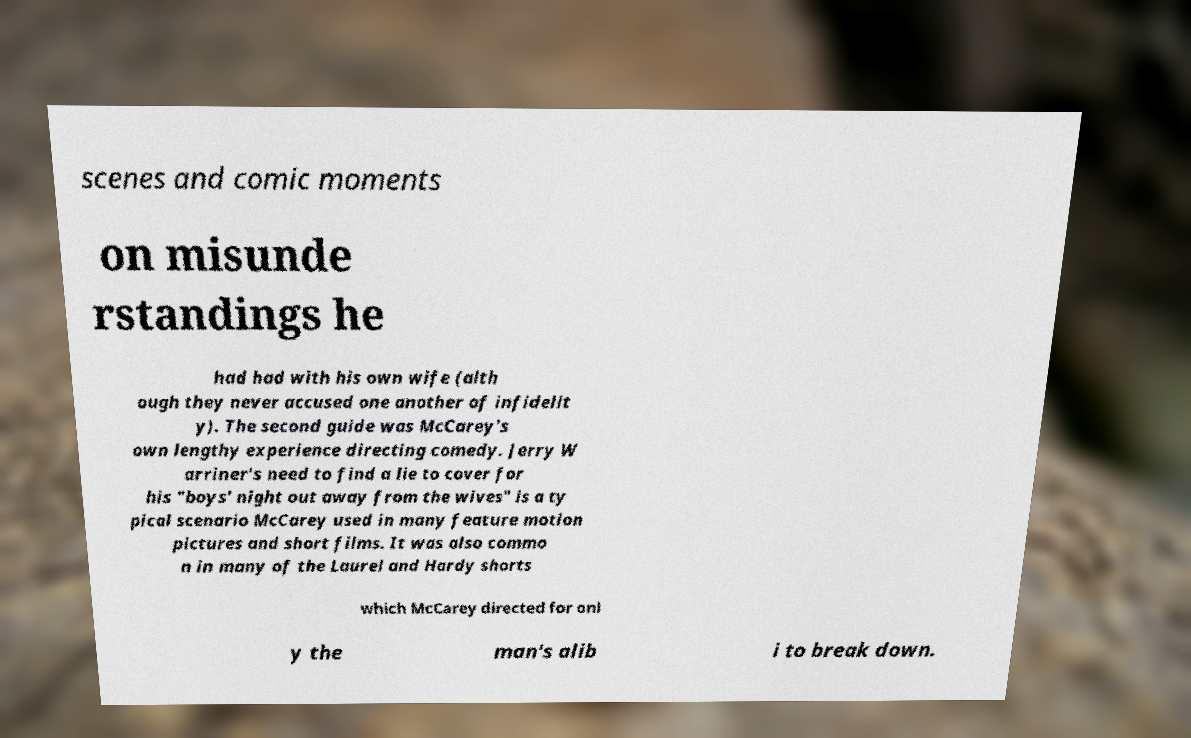Can you read and provide the text displayed in the image?This photo seems to have some interesting text. Can you extract and type it out for me? scenes and comic moments on misunde rstandings he had had with his own wife (alth ough they never accused one another of infidelit y). The second guide was McCarey's own lengthy experience directing comedy. Jerry W arriner's need to find a lie to cover for his "boys' night out away from the wives" is a ty pical scenario McCarey used in many feature motion pictures and short films. It was also commo n in many of the Laurel and Hardy shorts which McCarey directed for onl y the man's alib i to break down. 